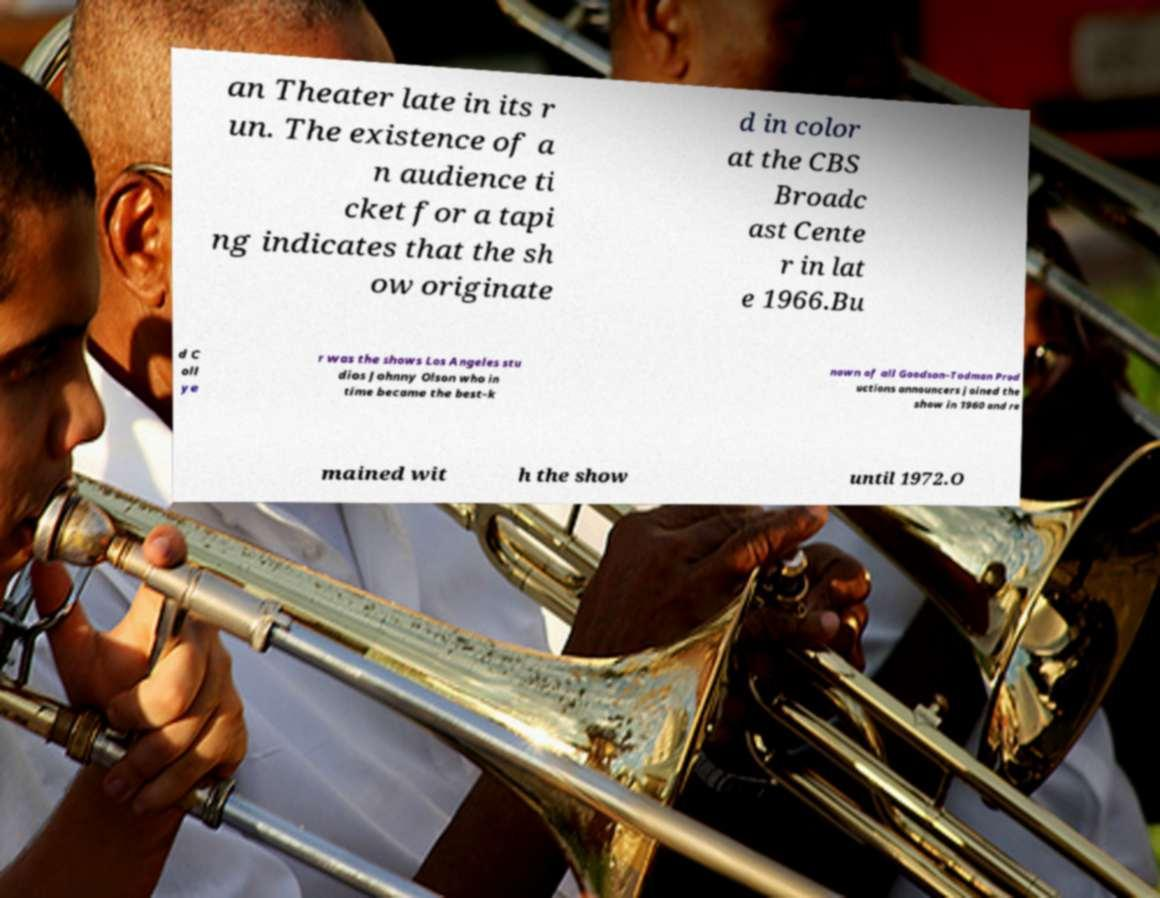For documentation purposes, I need the text within this image transcribed. Could you provide that? an Theater late in its r un. The existence of a n audience ti cket for a tapi ng indicates that the sh ow originate d in color at the CBS Broadc ast Cente r in lat e 1966.Bu d C oll ye r was the shows Los Angeles stu dios Johnny Olson who in time became the best-k nown of all Goodson–Todman Prod uctions announcers joined the show in 1960 and re mained wit h the show until 1972.O 